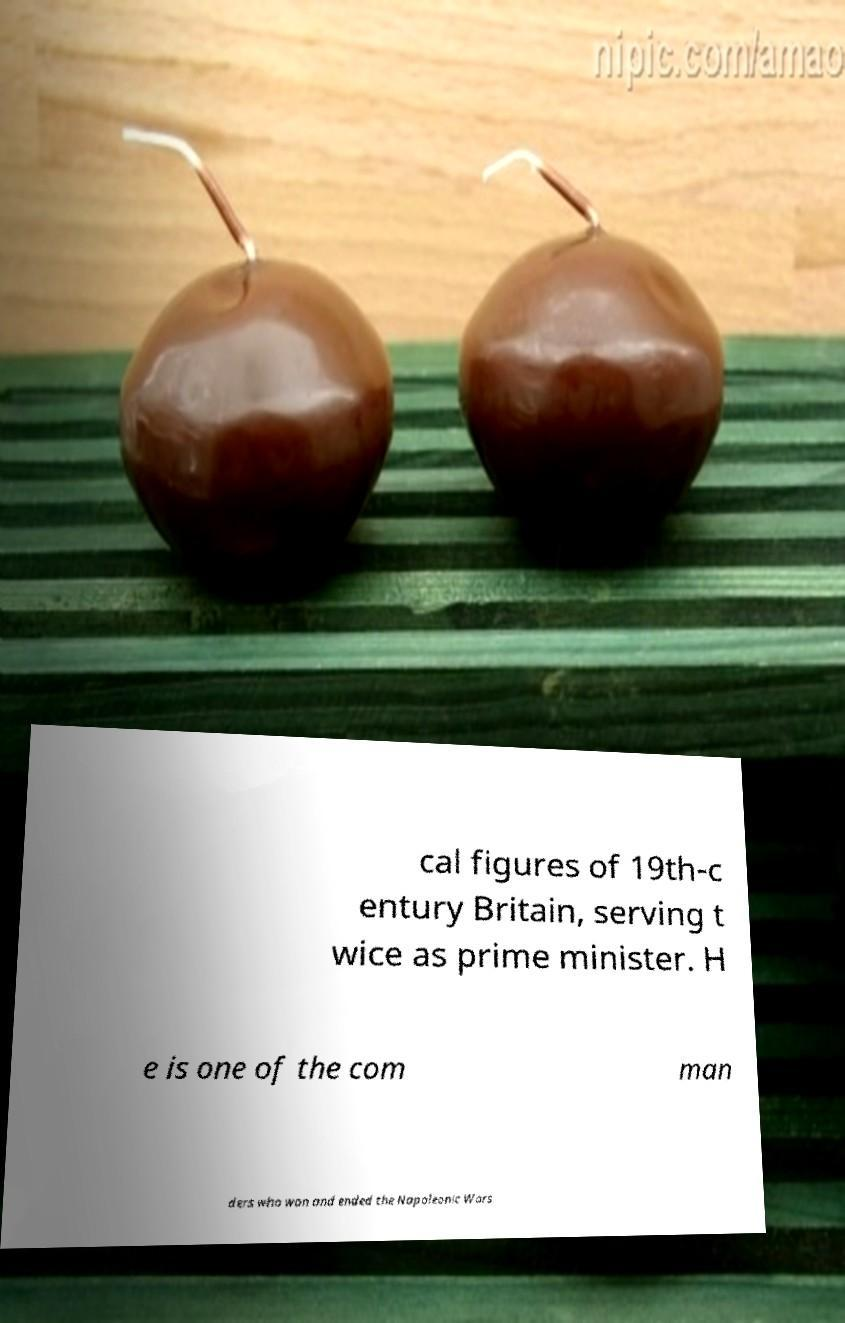Please identify and transcribe the text found in this image. cal figures of 19th-c entury Britain, serving t wice as prime minister. H e is one of the com man ders who won and ended the Napoleonic Wars 